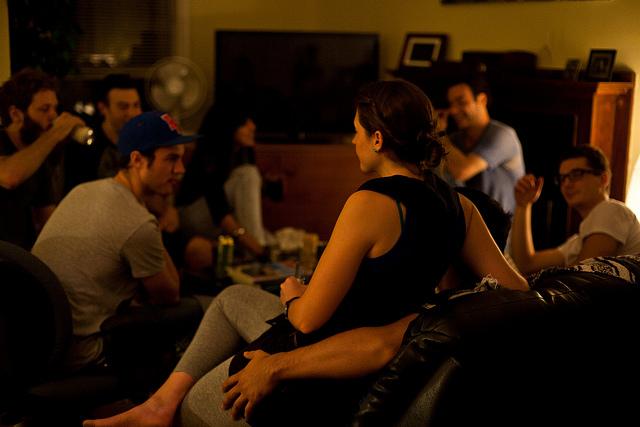Where is the man's left hand?
Be succinct. Leg. How many people?
Concise answer only. 8. Is the guy covering one of his ears to hear better?
Keep it brief. No. How many balloons are shown?
Concise answer only. 0. What are people doing in the room?
Give a very brief answer. Talking. What is this form of entertainment called?
Short answer required. Party. Is this a family meal?
Write a very short answer. No. What is the man cuddling with?
Be succinct. Woman. 